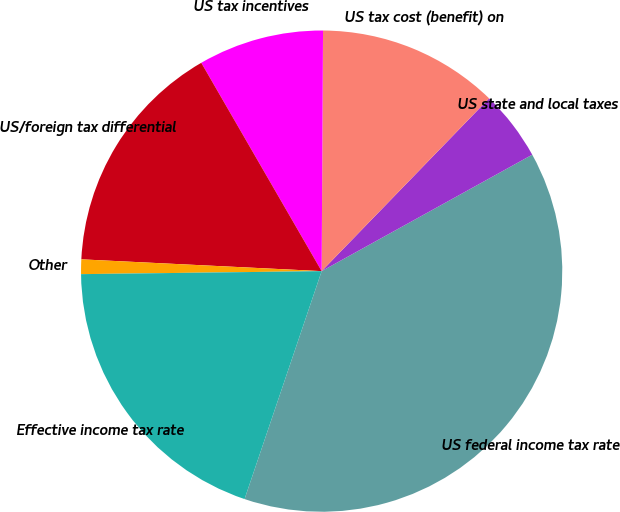Convert chart. <chart><loc_0><loc_0><loc_500><loc_500><pie_chart><fcel>US federal income tax rate<fcel>US state and local taxes<fcel>US tax cost (benefit) on<fcel>US tax incentives<fcel>US/foreign tax differential<fcel>Other<fcel>Effective income tax rate<nl><fcel>38.23%<fcel>4.71%<fcel>12.16%<fcel>8.43%<fcel>15.88%<fcel>0.98%<fcel>19.61%<nl></chart> 